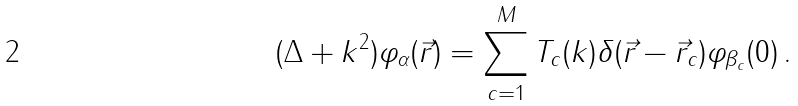Convert formula to latex. <formula><loc_0><loc_0><loc_500><loc_500>( \Delta + k ^ { 2 } ) \varphi _ { \alpha } ( \vec { r } ) = \sum _ { c = 1 } ^ { M } T _ { c } ( k ) \delta ( \vec { r } - \vec { r } _ { c } ) \varphi _ { \beta _ { c } } ( 0 ) \, .</formula> 